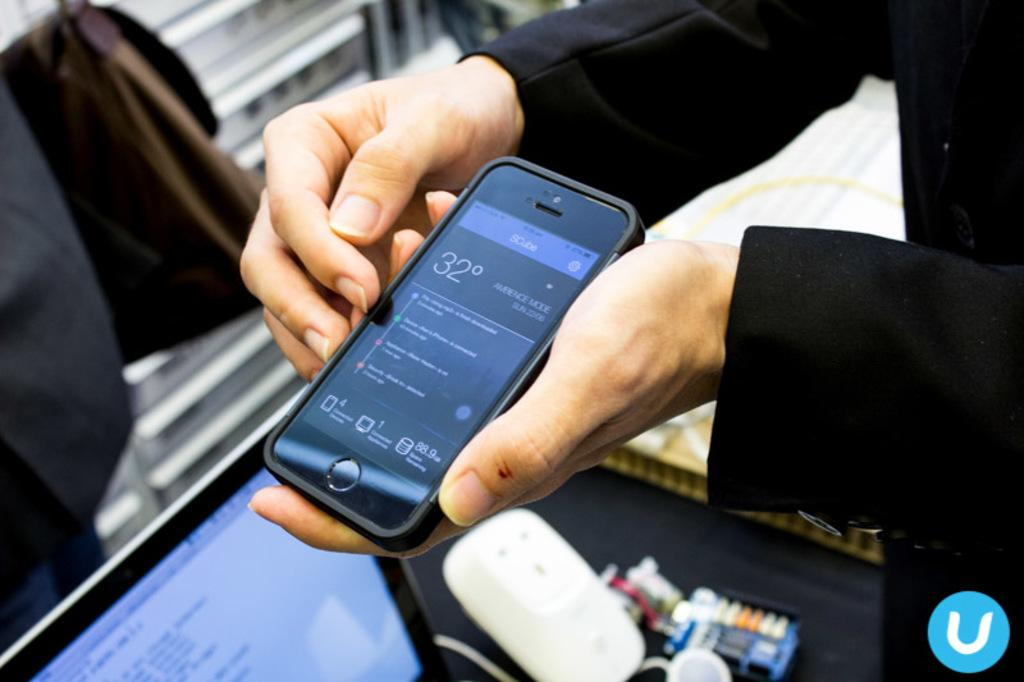<image>
Create a compact narrative representing the image presented. a black scube with a screen showing it is 32 degrees outside 